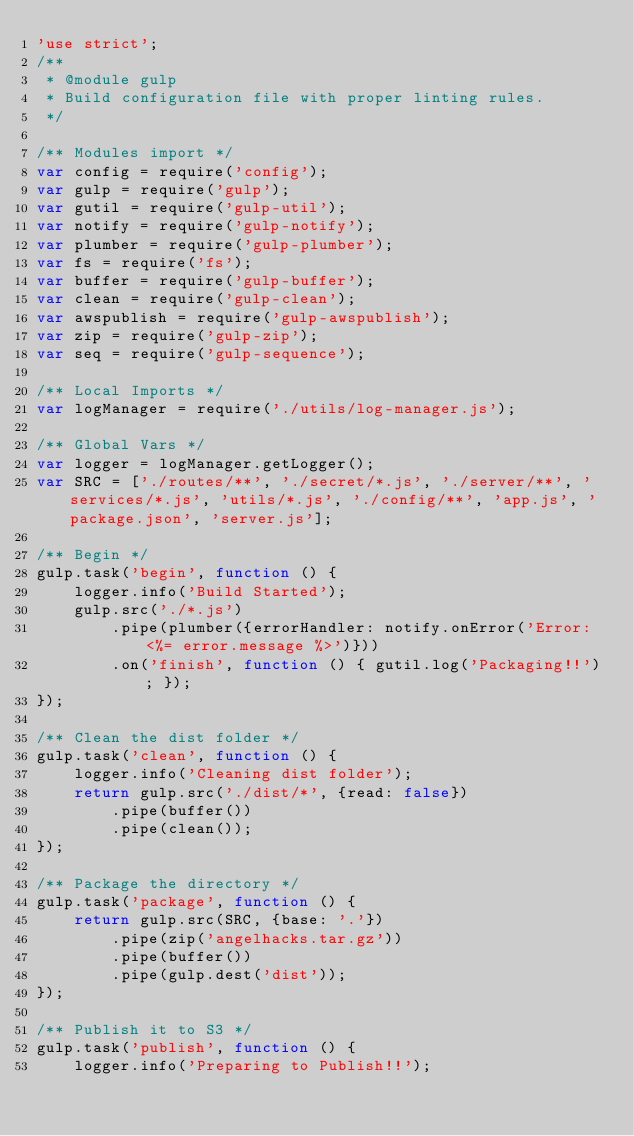Convert code to text. <code><loc_0><loc_0><loc_500><loc_500><_JavaScript_>'use strict';
/**
 * @module gulp
 * Build configuration file with proper linting rules.
 */

/** Modules import */
var config = require('config');
var gulp = require('gulp');
var gutil = require('gulp-util');
var notify = require('gulp-notify');
var plumber = require('gulp-plumber');
var fs = require('fs');
var buffer = require('gulp-buffer');
var clean = require('gulp-clean');
var awspublish = require('gulp-awspublish');
var zip = require('gulp-zip');
var seq = require('gulp-sequence');

/** Local Imports */
var logManager = require('./utils/log-manager.js');

/** Global Vars */
var logger = logManager.getLogger();
var SRC = ['./routes/**', './secret/*.js', './server/**', 'services/*.js', 'utils/*.js', './config/**', 'app.js', 'package.json', 'server.js'];

/** Begin */
gulp.task('begin', function () {
    logger.info('Build Started');
    gulp.src('./*.js')
        .pipe(plumber({errorHandler: notify.onError('Error: <%= error.message %>')}))
        .on('finish', function () { gutil.log('Packaging!!'); });
});

/** Clean the dist folder */
gulp.task('clean', function () {
    logger.info('Cleaning dist folder');
    return gulp.src('./dist/*', {read: false})
        .pipe(buffer())
        .pipe(clean());
});

/** Package the directory */
gulp.task('package', function () {
    return gulp.src(SRC, {base: '.'})
        .pipe(zip('angelhacks.tar.gz'))
        .pipe(buffer())
        .pipe(gulp.dest('dist'));
});

/** Publish it to S3 */
gulp.task('publish', function () {
    logger.info('Preparing to Publish!!');</code> 